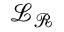<formula> <loc_0><loc_0><loc_500><loc_500>\mathcal { L } _ { \mathcal { R } }</formula> 